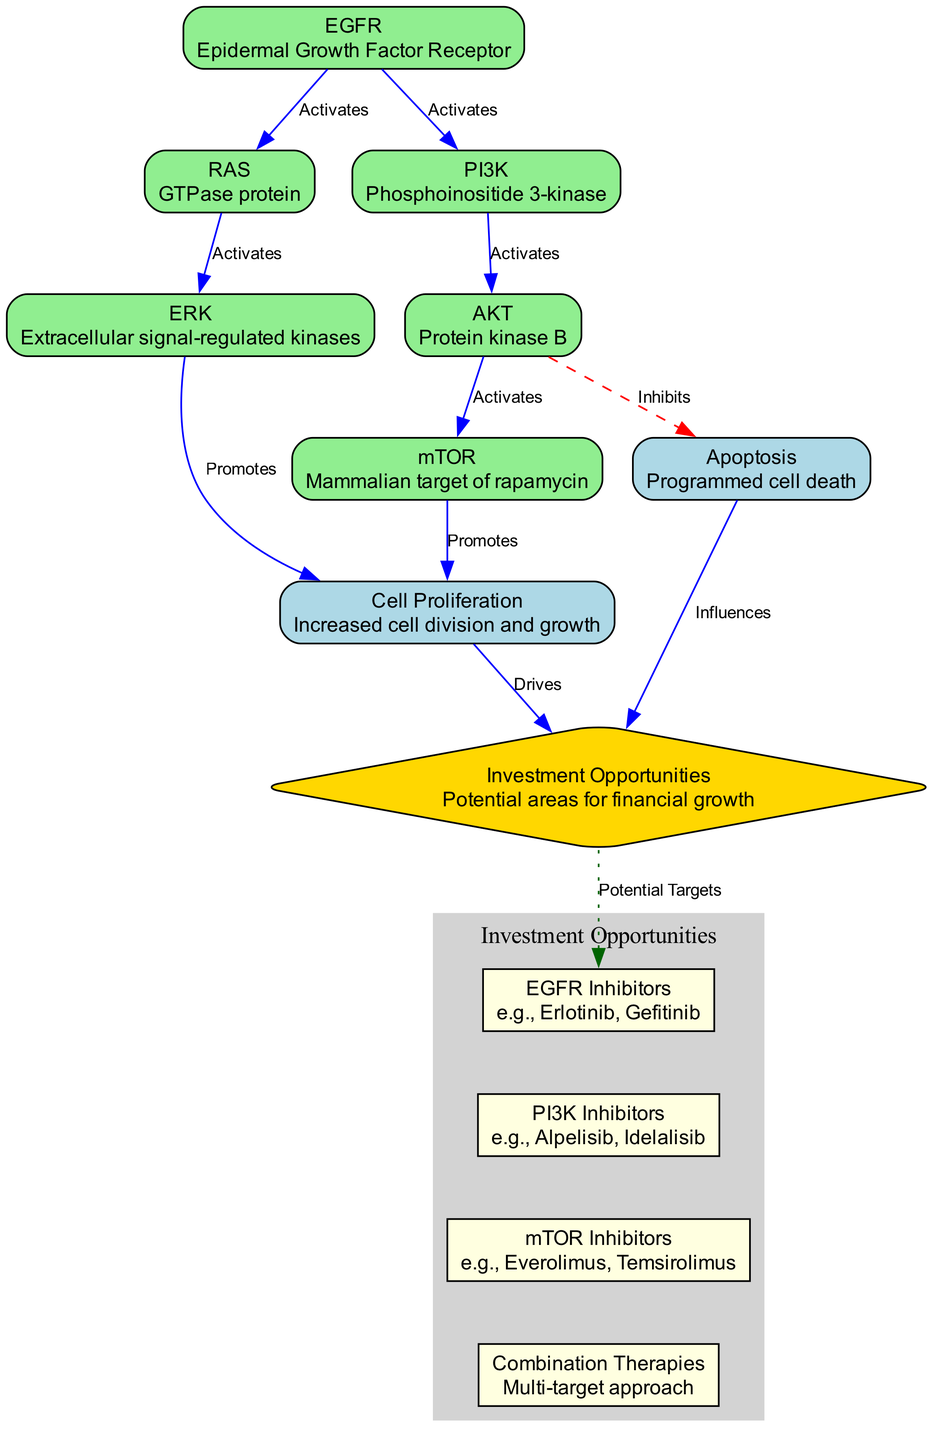What is the label of the node associated with cell death? The node related to programmed cell death is labeled "Apoptosis" and it specifically represents the process that leads to the programmed death of cells.
Answer: Apoptosis How many edges are directed out of the node 'AKT'? From the node 'AKT', there are two edges directed outwards: one to 'mTOR' (activates) and one to 'Apoptosis' (inhibits). Thus, the total count of outgoing edges from this node is two.
Answer: 2 Which node is directly activated by 'EGFR'? The node that is directly activated by 'EGFR' is 'RAS' and 'PI3K', as there are two edges emanating from 'EGFR' leading to these nodes. However, the question specifically asks for one, so just noting 'RAS' suffices as it’s the first mentioned.
Answer: RAS What relationship does 'AKT' have with 'Apoptosis'? 'AKT' has an 'Inhibits' relationship with 'Apoptosis,' indicating that the activation of 'AKT' leads to the suppression of cell death through apoptosis. This is visually represented by a dashed red edge between these two nodes.
Answer: Inhibits How does 'Cell Proliferation' relate to 'Investment Opportunities'? The relationship is that 'Cell Proliferation' drives 'Investment Opportunities,' meaning that increased cell division and growth has a significant influence on potential financial growth in the field of targeted therapies for cancer.
Answer: Drives Which inhibitors are associated with 'PI3K'? The inhibitors associated with 'PI3K' are referred to as 'PI3K Inhibitors,' and they include examples like Alpelisib and Idelalisib, as shown in the diagram alongside the 'Investment Opportunities' node.
Answer: PI3K Inhibitors List the pathways leading to 'Cell Proliferation'. The pathways leading to 'Cell Proliferation' include activation from both 'ERK' and 'mTOR'. Both activations create a direct impact on cell division and growth, as each node feeds into 'Cell Proliferation' from different sources in the diagram.
Answer: ERK, mTOR What type of therapies are indicated under 'Combination Therapies'? 'Combination Therapies' refers to a multi-target approach, meaning that it utilizes more than one type of therapy to target various pathways for a more effective treatment strategy.
Answer: Multi-target approach What is the color representing 'Investment Opportunities'? The color that represents 'Investment Opportunities' in the diagram is gold, indicated by the diamond shape of the node, which stands out compared to other nodes.
Answer: Gold 